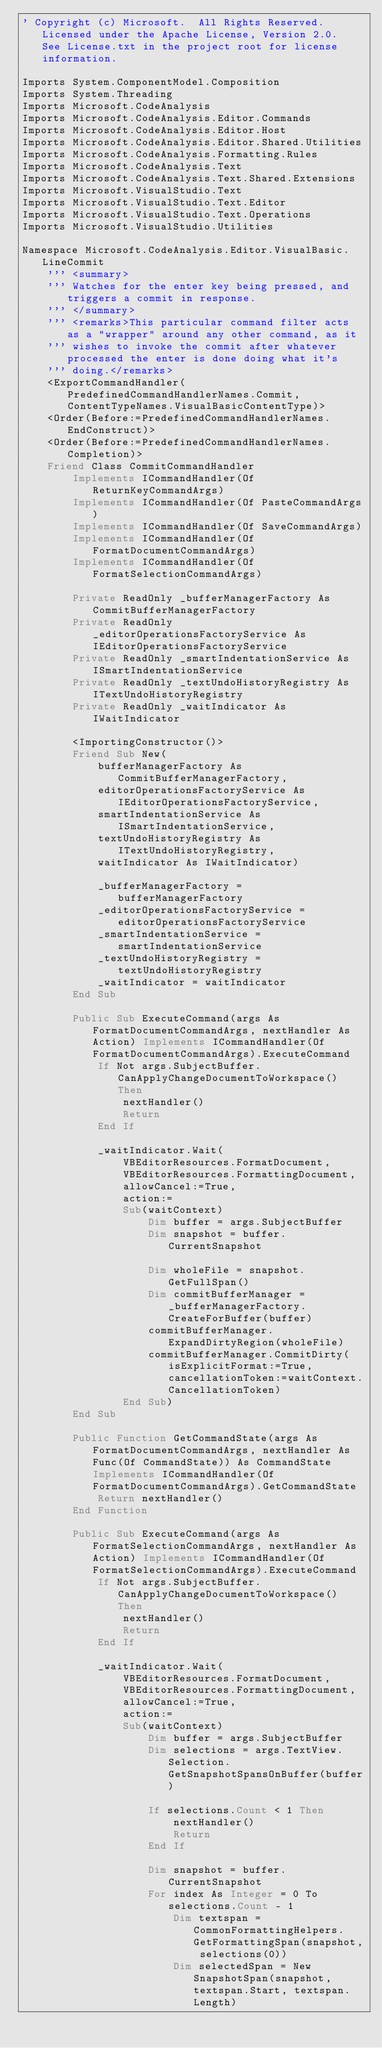Convert code to text. <code><loc_0><loc_0><loc_500><loc_500><_VisualBasic_>' Copyright (c) Microsoft.  All Rights Reserved.  Licensed under the Apache License, Version 2.0.  See License.txt in the project root for license information.

Imports System.ComponentModel.Composition
Imports System.Threading
Imports Microsoft.CodeAnalysis
Imports Microsoft.CodeAnalysis.Editor.Commands
Imports Microsoft.CodeAnalysis.Editor.Host
Imports Microsoft.CodeAnalysis.Editor.Shared.Utilities
Imports Microsoft.CodeAnalysis.Formatting.Rules
Imports Microsoft.CodeAnalysis.Text
Imports Microsoft.CodeAnalysis.Text.Shared.Extensions
Imports Microsoft.VisualStudio.Text
Imports Microsoft.VisualStudio.Text.Editor
Imports Microsoft.VisualStudio.Text.Operations
Imports Microsoft.VisualStudio.Utilities

Namespace Microsoft.CodeAnalysis.Editor.VisualBasic.LineCommit
    ''' <summary>
    ''' Watches for the enter key being pressed, and triggers a commit in response.
    ''' </summary>
    ''' <remarks>This particular command filter acts as a "wrapper" around any other command, as it
    ''' wishes to invoke the commit after whatever processed the enter is done doing what it's
    ''' doing.</remarks>
    <ExportCommandHandler(PredefinedCommandHandlerNames.Commit, ContentTypeNames.VisualBasicContentType)>
    <Order(Before:=PredefinedCommandHandlerNames.EndConstruct)>
    <Order(Before:=PredefinedCommandHandlerNames.Completion)>
    Friend Class CommitCommandHandler
        Implements ICommandHandler(Of ReturnKeyCommandArgs)
        Implements ICommandHandler(Of PasteCommandArgs)
        Implements ICommandHandler(Of SaveCommandArgs)
        Implements ICommandHandler(Of FormatDocumentCommandArgs)
        Implements ICommandHandler(Of FormatSelectionCommandArgs)

        Private ReadOnly _bufferManagerFactory As CommitBufferManagerFactory
        Private ReadOnly _editorOperationsFactoryService As IEditorOperationsFactoryService
        Private ReadOnly _smartIndentationService As ISmartIndentationService
        Private ReadOnly _textUndoHistoryRegistry As ITextUndoHistoryRegistry
        Private ReadOnly _waitIndicator As IWaitIndicator

        <ImportingConstructor()>
        Friend Sub New(
            bufferManagerFactory As CommitBufferManagerFactory,
            editorOperationsFactoryService As IEditorOperationsFactoryService,
            smartIndentationService As ISmartIndentationService,
            textUndoHistoryRegistry As ITextUndoHistoryRegistry,
            waitIndicator As IWaitIndicator)

            _bufferManagerFactory = bufferManagerFactory
            _editorOperationsFactoryService = editorOperationsFactoryService
            _smartIndentationService = smartIndentationService
            _textUndoHistoryRegistry = textUndoHistoryRegistry
            _waitIndicator = waitIndicator
        End Sub

        Public Sub ExecuteCommand(args As FormatDocumentCommandArgs, nextHandler As Action) Implements ICommandHandler(Of FormatDocumentCommandArgs).ExecuteCommand
            If Not args.SubjectBuffer.CanApplyChangeDocumentToWorkspace() Then
                nextHandler()
                Return
            End If

            _waitIndicator.Wait(
                VBEditorResources.FormatDocument,
                VBEditorResources.FormattingDocument,
                allowCancel:=True,
                action:=
                Sub(waitContext)
                    Dim buffer = args.SubjectBuffer
                    Dim snapshot = buffer.CurrentSnapshot

                    Dim wholeFile = snapshot.GetFullSpan()
                    Dim commitBufferManager = _bufferManagerFactory.CreateForBuffer(buffer)
                    commitBufferManager.ExpandDirtyRegion(wholeFile)
                    commitBufferManager.CommitDirty(isExplicitFormat:=True, cancellationToken:=waitContext.CancellationToken)
                End Sub)
        End Sub

        Public Function GetCommandState(args As FormatDocumentCommandArgs, nextHandler As Func(Of CommandState)) As CommandState Implements ICommandHandler(Of FormatDocumentCommandArgs).GetCommandState
            Return nextHandler()
        End Function

        Public Sub ExecuteCommand(args As FormatSelectionCommandArgs, nextHandler As Action) Implements ICommandHandler(Of FormatSelectionCommandArgs).ExecuteCommand
            If Not args.SubjectBuffer.CanApplyChangeDocumentToWorkspace() Then
                nextHandler()
                Return
            End If

            _waitIndicator.Wait(
                VBEditorResources.FormatDocument,
                VBEditorResources.FormattingDocument,
                allowCancel:=True,
                action:=
                Sub(waitContext)
                    Dim buffer = args.SubjectBuffer
                    Dim selections = args.TextView.Selection.GetSnapshotSpansOnBuffer(buffer)

                    If selections.Count < 1 Then
                        nextHandler()
                        Return
                    End If

                    Dim snapshot = buffer.CurrentSnapshot
                    For index As Integer = 0 To selections.Count - 1
                        Dim textspan = CommonFormattingHelpers.GetFormattingSpan(snapshot, selections(0))
                        Dim selectedSpan = New SnapshotSpan(snapshot, textspan.Start, textspan.Length)</code> 